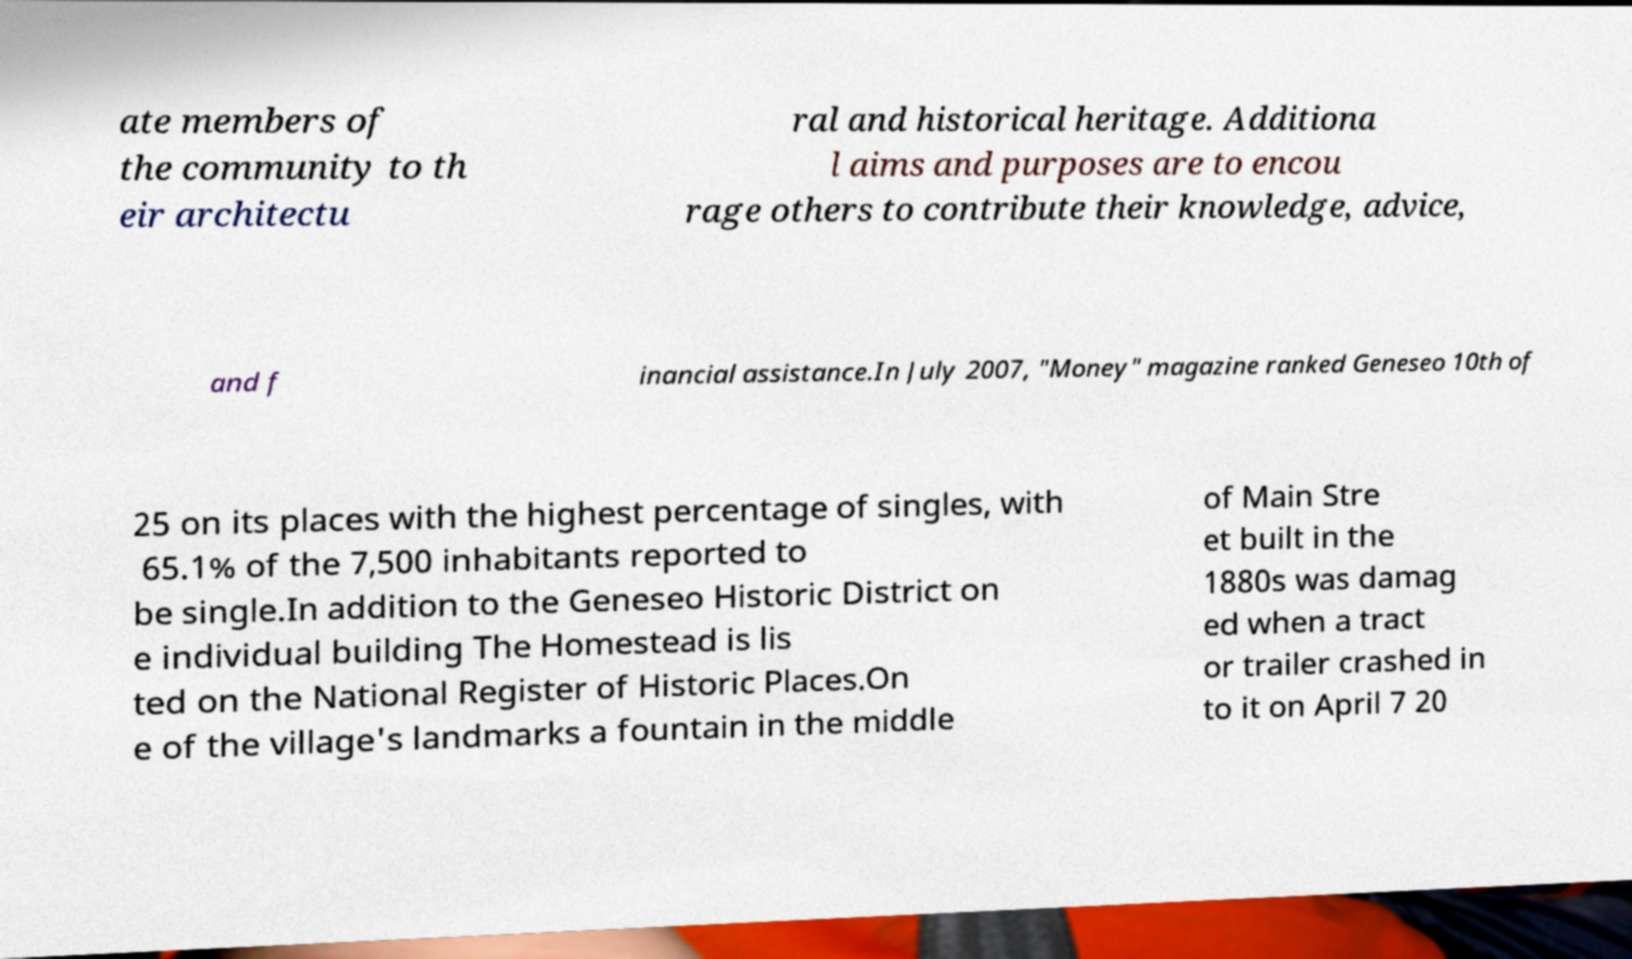There's text embedded in this image that I need extracted. Can you transcribe it verbatim? ate members of the community to th eir architectu ral and historical heritage. Additiona l aims and purposes are to encou rage others to contribute their knowledge, advice, and f inancial assistance.In July 2007, "Money" magazine ranked Geneseo 10th of 25 on its places with the highest percentage of singles, with 65.1% of the 7,500 inhabitants reported to be single.In addition to the Geneseo Historic District on e individual building The Homestead is lis ted on the National Register of Historic Places.On e of the village's landmarks a fountain in the middle of Main Stre et built in the 1880s was damag ed when a tract or trailer crashed in to it on April 7 20 